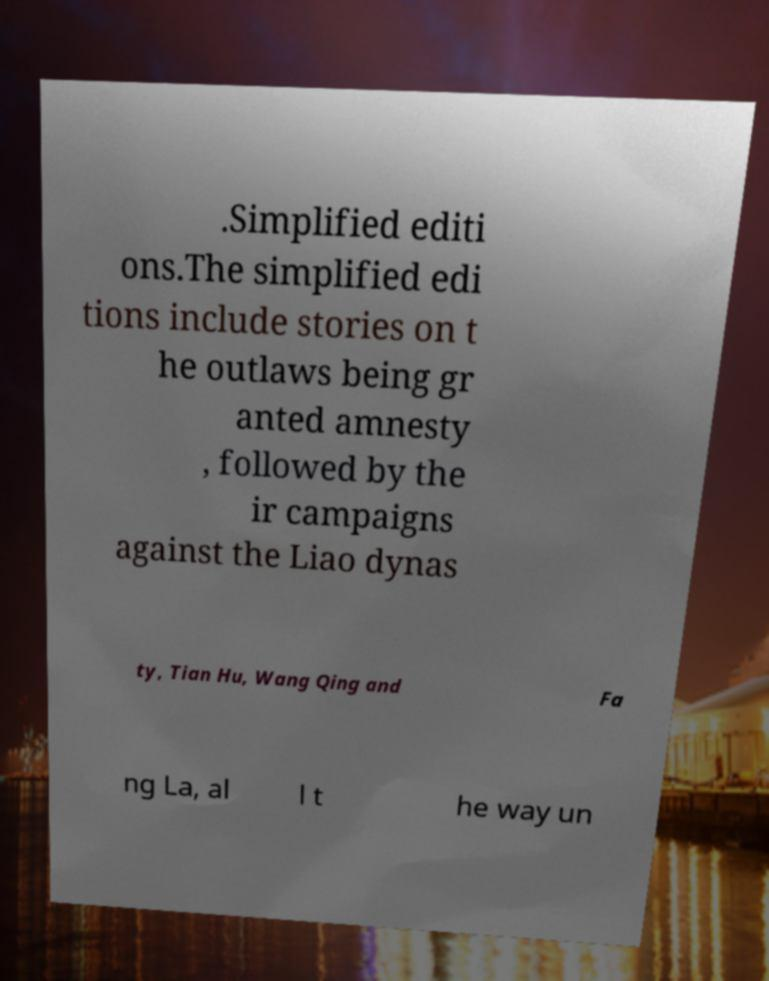For documentation purposes, I need the text within this image transcribed. Could you provide that? .Simplified editi ons.The simplified edi tions include stories on t he outlaws being gr anted amnesty , followed by the ir campaigns against the Liao dynas ty, Tian Hu, Wang Qing and Fa ng La, al l t he way un 